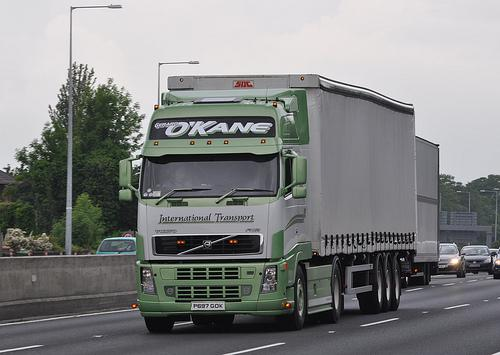Question: what type of truck is this?
Choices:
A. Fire truck.
B. Delivery truck.
C. A semi truck.
D. Food truck.
Answer with the letter. Answer: C Question: what color are the road markings?
Choices:
A. Yellow.
B. Grey.
C. Red.
D. White.
Answer with the letter. Answer: D Question: where are the passenger cars?
Choices:
A. In the parking lot.
B. On the ferry.
C. In the sales lot.
D. Behind the semi trucks.
Answer with the letter. Answer: D Question: where are the trees?
Choices:
A. In front of the house.
B. Across the road.
C. In the park.
D. In the yard.
Answer with the letter. Answer: B 